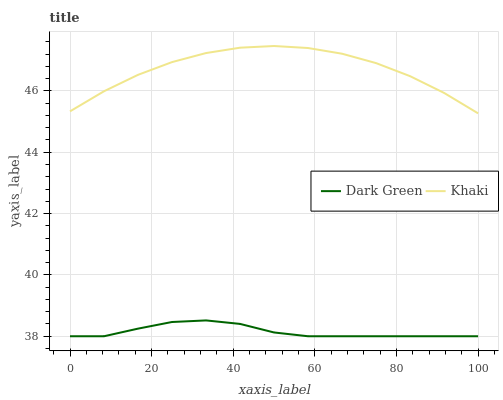Does Dark Green have the minimum area under the curve?
Answer yes or no. Yes. Does Khaki have the maximum area under the curve?
Answer yes or no. Yes. Does Dark Green have the maximum area under the curve?
Answer yes or no. No. Is Dark Green the smoothest?
Answer yes or no. Yes. Is Khaki the roughest?
Answer yes or no. Yes. Is Dark Green the roughest?
Answer yes or no. No. Does Dark Green have the lowest value?
Answer yes or no. Yes. Does Khaki have the highest value?
Answer yes or no. Yes. Does Dark Green have the highest value?
Answer yes or no. No. Is Dark Green less than Khaki?
Answer yes or no. Yes. Is Khaki greater than Dark Green?
Answer yes or no. Yes. Does Dark Green intersect Khaki?
Answer yes or no. No. 